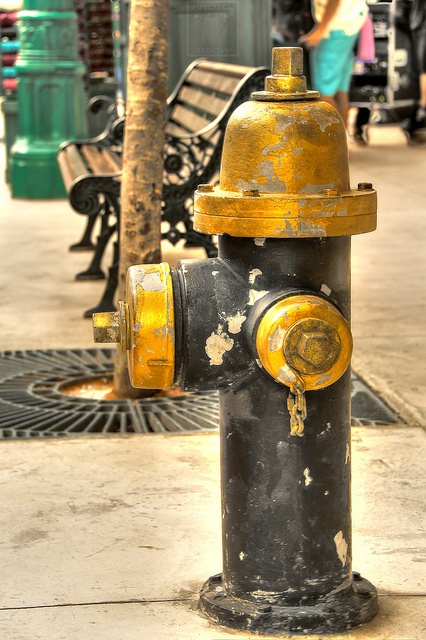Describe the objects in this image and their specific colors. I can see fire hydrant in white, black, gray, and olive tones, bench in white, black, gray, and tan tones, people in white, lightyellow, and turquoise tones, people in white, black, and gray tones, and handbag in white, lightpink, gray, and salmon tones in this image. 